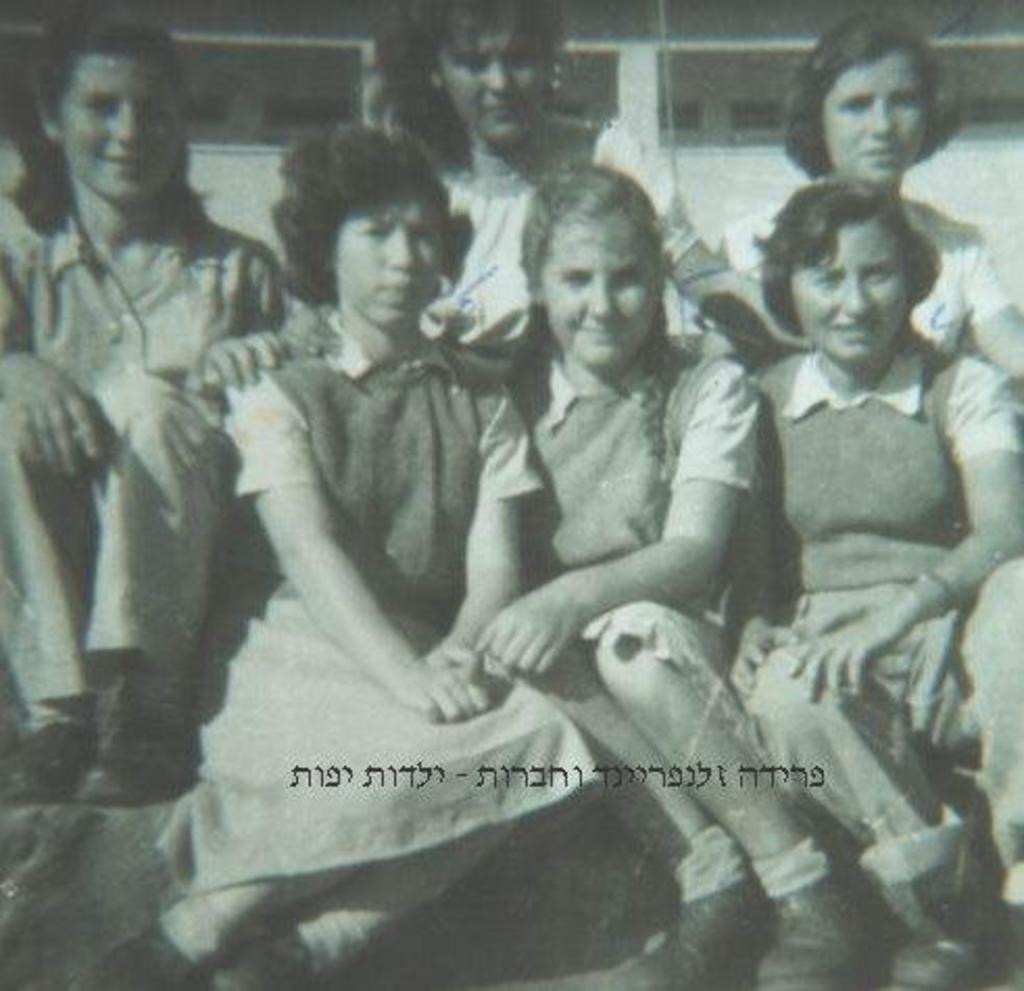Describe this image in one or two sentences. In this image there are some girls who are sitting, in the background there is a building. 